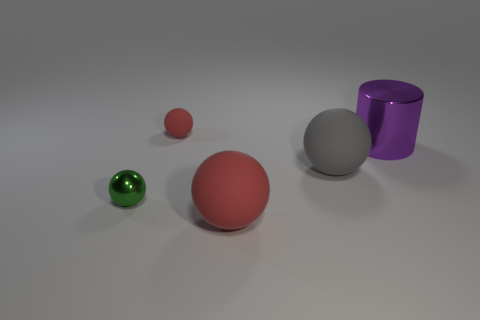Is the number of purple shiny things behind the large purple metallic cylinder the same as the number of tiny red objects that are to the left of the tiny green metallic object?
Your answer should be compact. Yes. How many metal balls are behind the red sphere in front of the tiny sphere in front of the small matte ball?
Your response must be concise. 1. Does the big shiny cylinder have the same color as the matte object that is in front of the tiny green shiny sphere?
Your answer should be very brief. No. The gray ball that is made of the same material as the big red ball is what size?
Your response must be concise. Large. Is the number of shiny things to the right of the small red rubber thing greater than the number of big purple objects?
Provide a short and direct response. No. What material is the red object to the right of the red object that is behind the matte ball that is on the right side of the large red object?
Give a very brief answer. Rubber. Is the material of the small red sphere the same as the tiny object left of the small red matte object?
Offer a terse response. No. There is another big object that is the same shape as the large gray thing; what is it made of?
Provide a short and direct response. Rubber. Is there anything else that has the same material as the purple cylinder?
Give a very brief answer. Yes. Is the number of big things that are behind the small green shiny sphere greater than the number of big purple cylinders that are to the left of the large gray matte sphere?
Make the answer very short. Yes. 